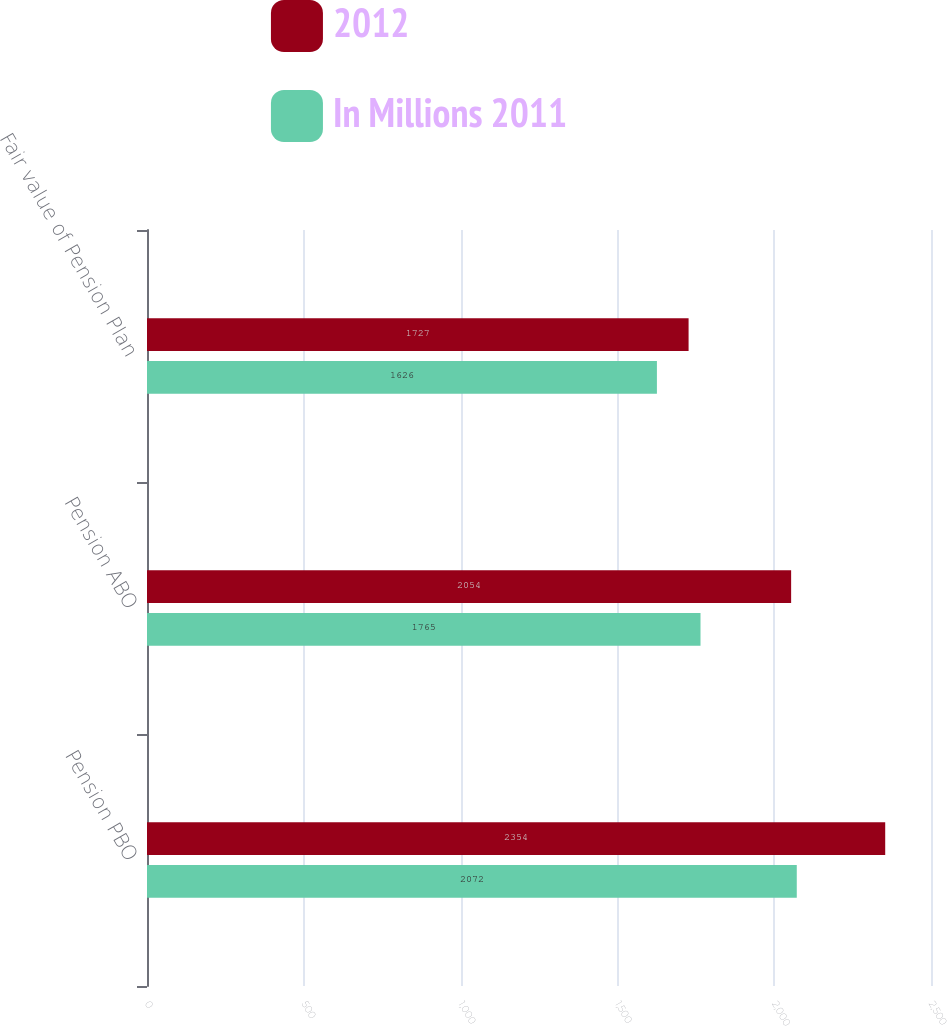Convert chart. <chart><loc_0><loc_0><loc_500><loc_500><stacked_bar_chart><ecel><fcel>Pension PBO<fcel>Pension ABO<fcel>Fair value of Pension Plan<nl><fcel>2012<fcel>2354<fcel>2054<fcel>1727<nl><fcel>In Millions 2011<fcel>2072<fcel>1765<fcel>1626<nl></chart> 